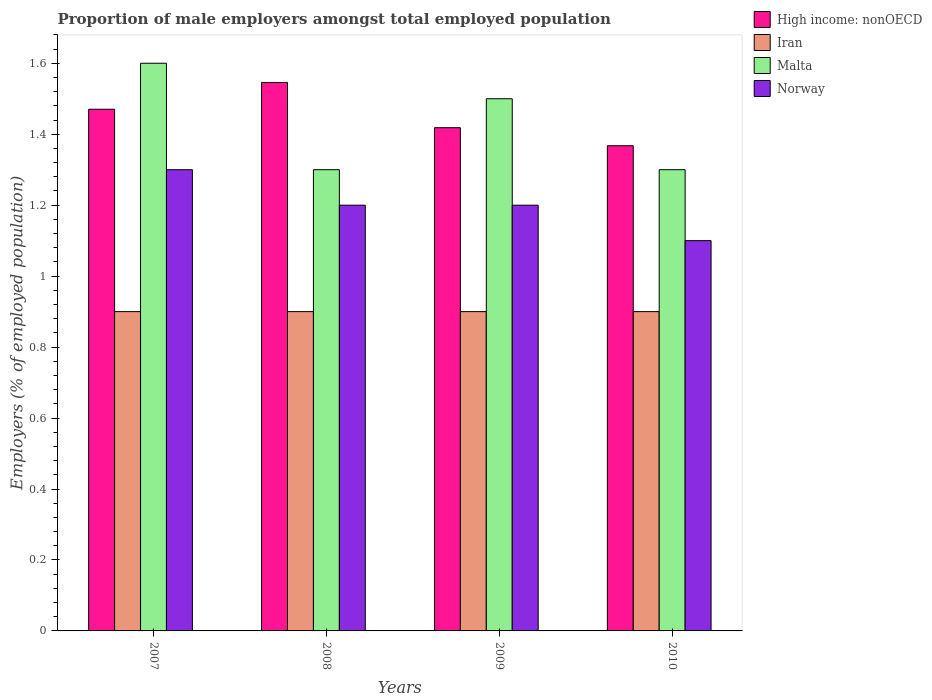How many bars are there on the 4th tick from the left?
Give a very brief answer. 4. How many bars are there on the 2nd tick from the right?
Provide a succinct answer. 4. In how many cases, is the number of bars for a given year not equal to the number of legend labels?
Provide a succinct answer. 0. What is the proportion of male employers in Norway in 2010?
Your answer should be compact. 1.1. Across all years, what is the maximum proportion of male employers in High income: nonOECD?
Give a very brief answer. 1.55. Across all years, what is the minimum proportion of male employers in Malta?
Ensure brevity in your answer.  1.3. In which year was the proportion of male employers in Norway minimum?
Provide a short and direct response. 2010. What is the total proportion of male employers in Norway in the graph?
Ensure brevity in your answer.  4.8. What is the difference between the proportion of male employers in Norway in 2007 and the proportion of male employers in Iran in 2009?
Your answer should be very brief. 0.4. What is the average proportion of male employers in Norway per year?
Provide a succinct answer. 1.2. In the year 2008, what is the difference between the proportion of male employers in Norway and proportion of male employers in High income: nonOECD?
Offer a terse response. -0.35. What is the ratio of the proportion of male employers in Norway in 2008 to that in 2009?
Your answer should be very brief. 1. Is the proportion of male employers in Iran in 2007 less than that in 2008?
Give a very brief answer. No. Is the difference between the proportion of male employers in Norway in 2008 and 2010 greater than the difference between the proportion of male employers in High income: nonOECD in 2008 and 2010?
Keep it short and to the point. No. What is the difference between the highest and the second highest proportion of male employers in Malta?
Offer a very short reply. 0.1. What is the difference between the highest and the lowest proportion of male employers in Malta?
Provide a succinct answer. 0.3. In how many years, is the proportion of male employers in High income: nonOECD greater than the average proportion of male employers in High income: nonOECD taken over all years?
Offer a very short reply. 2. What does the 2nd bar from the left in 2007 represents?
Offer a terse response. Iran. What does the 2nd bar from the right in 2009 represents?
Your answer should be compact. Malta. Is it the case that in every year, the sum of the proportion of male employers in High income: nonOECD and proportion of male employers in Malta is greater than the proportion of male employers in Iran?
Offer a terse response. Yes. Are all the bars in the graph horizontal?
Offer a terse response. No. What is the difference between two consecutive major ticks on the Y-axis?
Provide a short and direct response. 0.2. Does the graph contain any zero values?
Give a very brief answer. No. Where does the legend appear in the graph?
Make the answer very short. Top right. How many legend labels are there?
Make the answer very short. 4. How are the legend labels stacked?
Ensure brevity in your answer.  Vertical. What is the title of the graph?
Offer a very short reply. Proportion of male employers amongst total employed population. Does "Mauritius" appear as one of the legend labels in the graph?
Keep it short and to the point. No. What is the label or title of the X-axis?
Offer a very short reply. Years. What is the label or title of the Y-axis?
Offer a very short reply. Employers (% of employed population). What is the Employers (% of employed population) in High income: nonOECD in 2007?
Your answer should be very brief. 1.47. What is the Employers (% of employed population) of Iran in 2007?
Your answer should be very brief. 0.9. What is the Employers (% of employed population) of Malta in 2007?
Your answer should be compact. 1.6. What is the Employers (% of employed population) in Norway in 2007?
Make the answer very short. 1.3. What is the Employers (% of employed population) of High income: nonOECD in 2008?
Your response must be concise. 1.55. What is the Employers (% of employed population) of Iran in 2008?
Give a very brief answer. 0.9. What is the Employers (% of employed population) of Malta in 2008?
Provide a succinct answer. 1.3. What is the Employers (% of employed population) of Norway in 2008?
Your answer should be compact. 1.2. What is the Employers (% of employed population) in High income: nonOECD in 2009?
Provide a succinct answer. 1.42. What is the Employers (% of employed population) in Iran in 2009?
Keep it short and to the point. 0.9. What is the Employers (% of employed population) in Norway in 2009?
Offer a terse response. 1.2. What is the Employers (% of employed population) of High income: nonOECD in 2010?
Keep it short and to the point. 1.37. What is the Employers (% of employed population) of Iran in 2010?
Keep it short and to the point. 0.9. What is the Employers (% of employed population) in Malta in 2010?
Make the answer very short. 1.3. What is the Employers (% of employed population) of Norway in 2010?
Provide a succinct answer. 1.1. Across all years, what is the maximum Employers (% of employed population) of High income: nonOECD?
Provide a short and direct response. 1.55. Across all years, what is the maximum Employers (% of employed population) of Iran?
Provide a succinct answer. 0.9. Across all years, what is the maximum Employers (% of employed population) in Malta?
Keep it short and to the point. 1.6. Across all years, what is the maximum Employers (% of employed population) in Norway?
Make the answer very short. 1.3. Across all years, what is the minimum Employers (% of employed population) in High income: nonOECD?
Offer a very short reply. 1.37. Across all years, what is the minimum Employers (% of employed population) of Iran?
Provide a succinct answer. 0.9. Across all years, what is the minimum Employers (% of employed population) of Malta?
Provide a succinct answer. 1.3. Across all years, what is the minimum Employers (% of employed population) of Norway?
Provide a short and direct response. 1.1. What is the total Employers (% of employed population) in High income: nonOECD in the graph?
Make the answer very short. 5.8. What is the total Employers (% of employed population) of Norway in the graph?
Your answer should be very brief. 4.8. What is the difference between the Employers (% of employed population) of High income: nonOECD in 2007 and that in 2008?
Make the answer very short. -0.08. What is the difference between the Employers (% of employed population) of Iran in 2007 and that in 2008?
Provide a succinct answer. 0. What is the difference between the Employers (% of employed population) in Norway in 2007 and that in 2008?
Offer a very short reply. 0.1. What is the difference between the Employers (% of employed population) of High income: nonOECD in 2007 and that in 2009?
Offer a terse response. 0.05. What is the difference between the Employers (% of employed population) in Malta in 2007 and that in 2009?
Offer a very short reply. 0.1. What is the difference between the Employers (% of employed population) of High income: nonOECD in 2007 and that in 2010?
Provide a succinct answer. 0.1. What is the difference between the Employers (% of employed population) of Iran in 2007 and that in 2010?
Provide a short and direct response. 0. What is the difference between the Employers (% of employed population) in Malta in 2007 and that in 2010?
Your response must be concise. 0.3. What is the difference between the Employers (% of employed population) of Norway in 2007 and that in 2010?
Your response must be concise. 0.2. What is the difference between the Employers (% of employed population) in High income: nonOECD in 2008 and that in 2009?
Offer a very short reply. 0.13. What is the difference between the Employers (% of employed population) of High income: nonOECD in 2008 and that in 2010?
Provide a short and direct response. 0.18. What is the difference between the Employers (% of employed population) of Iran in 2008 and that in 2010?
Keep it short and to the point. 0. What is the difference between the Employers (% of employed population) of Norway in 2008 and that in 2010?
Offer a very short reply. 0.1. What is the difference between the Employers (% of employed population) of High income: nonOECD in 2009 and that in 2010?
Provide a succinct answer. 0.05. What is the difference between the Employers (% of employed population) of Malta in 2009 and that in 2010?
Ensure brevity in your answer.  0.2. What is the difference between the Employers (% of employed population) of Norway in 2009 and that in 2010?
Provide a short and direct response. 0.1. What is the difference between the Employers (% of employed population) of High income: nonOECD in 2007 and the Employers (% of employed population) of Iran in 2008?
Your answer should be very brief. 0.57. What is the difference between the Employers (% of employed population) in High income: nonOECD in 2007 and the Employers (% of employed population) in Malta in 2008?
Offer a very short reply. 0.17. What is the difference between the Employers (% of employed population) of High income: nonOECD in 2007 and the Employers (% of employed population) of Norway in 2008?
Provide a succinct answer. 0.27. What is the difference between the Employers (% of employed population) of Iran in 2007 and the Employers (% of employed population) of Malta in 2008?
Offer a very short reply. -0.4. What is the difference between the Employers (% of employed population) in Malta in 2007 and the Employers (% of employed population) in Norway in 2008?
Ensure brevity in your answer.  0.4. What is the difference between the Employers (% of employed population) of High income: nonOECD in 2007 and the Employers (% of employed population) of Iran in 2009?
Make the answer very short. 0.57. What is the difference between the Employers (% of employed population) of High income: nonOECD in 2007 and the Employers (% of employed population) of Malta in 2009?
Your response must be concise. -0.03. What is the difference between the Employers (% of employed population) of High income: nonOECD in 2007 and the Employers (% of employed population) of Norway in 2009?
Your response must be concise. 0.27. What is the difference between the Employers (% of employed population) in Iran in 2007 and the Employers (% of employed population) in Norway in 2009?
Offer a terse response. -0.3. What is the difference between the Employers (% of employed population) in Malta in 2007 and the Employers (% of employed population) in Norway in 2009?
Give a very brief answer. 0.4. What is the difference between the Employers (% of employed population) in High income: nonOECD in 2007 and the Employers (% of employed population) in Iran in 2010?
Keep it short and to the point. 0.57. What is the difference between the Employers (% of employed population) in High income: nonOECD in 2007 and the Employers (% of employed population) in Malta in 2010?
Make the answer very short. 0.17. What is the difference between the Employers (% of employed population) in High income: nonOECD in 2007 and the Employers (% of employed population) in Norway in 2010?
Ensure brevity in your answer.  0.37. What is the difference between the Employers (% of employed population) in Iran in 2007 and the Employers (% of employed population) in Malta in 2010?
Offer a terse response. -0.4. What is the difference between the Employers (% of employed population) in High income: nonOECD in 2008 and the Employers (% of employed population) in Iran in 2009?
Offer a very short reply. 0.65. What is the difference between the Employers (% of employed population) in High income: nonOECD in 2008 and the Employers (% of employed population) in Malta in 2009?
Provide a short and direct response. 0.05. What is the difference between the Employers (% of employed population) of High income: nonOECD in 2008 and the Employers (% of employed population) of Norway in 2009?
Provide a succinct answer. 0.35. What is the difference between the Employers (% of employed population) in Iran in 2008 and the Employers (% of employed population) in Malta in 2009?
Provide a succinct answer. -0.6. What is the difference between the Employers (% of employed population) of Iran in 2008 and the Employers (% of employed population) of Norway in 2009?
Provide a succinct answer. -0.3. What is the difference between the Employers (% of employed population) of High income: nonOECD in 2008 and the Employers (% of employed population) of Iran in 2010?
Provide a short and direct response. 0.65. What is the difference between the Employers (% of employed population) of High income: nonOECD in 2008 and the Employers (% of employed population) of Malta in 2010?
Offer a terse response. 0.25. What is the difference between the Employers (% of employed population) in High income: nonOECD in 2008 and the Employers (% of employed population) in Norway in 2010?
Provide a short and direct response. 0.45. What is the difference between the Employers (% of employed population) of Iran in 2008 and the Employers (% of employed population) of Malta in 2010?
Provide a succinct answer. -0.4. What is the difference between the Employers (% of employed population) in Iran in 2008 and the Employers (% of employed population) in Norway in 2010?
Your response must be concise. -0.2. What is the difference between the Employers (% of employed population) in Malta in 2008 and the Employers (% of employed population) in Norway in 2010?
Provide a short and direct response. 0.2. What is the difference between the Employers (% of employed population) in High income: nonOECD in 2009 and the Employers (% of employed population) in Iran in 2010?
Give a very brief answer. 0.52. What is the difference between the Employers (% of employed population) of High income: nonOECD in 2009 and the Employers (% of employed population) of Malta in 2010?
Keep it short and to the point. 0.12. What is the difference between the Employers (% of employed population) in High income: nonOECD in 2009 and the Employers (% of employed population) in Norway in 2010?
Keep it short and to the point. 0.32. What is the difference between the Employers (% of employed population) in Iran in 2009 and the Employers (% of employed population) in Norway in 2010?
Make the answer very short. -0.2. What is the difference between the Employers (% of employed population) in Malta in 2009 and the Employers (% of employed population) in Norway in 2010?
Give a very brief answer. 0.4. What is the average Employers (% of employed population) of High income: nonOECD per year?
Your answer should be compact. 1.45. What is the average Employers (% of employed population) in Iran per year?
Your answer should be compact. 0.9. What is the average Employers (% of employed population) in Malta per year?
Your answer should be compact. 1.43. In the year 2007, what is the difference between the Employers (% of employed population) in High income: nonOECD and Employers (% of employed population) in Iran?
Give a very brief answer. 0.57. In the year 2007, what is the difference between the Employers (% of employed population) in High income: nonOECD and Employers (% of employed population) in Malta?
Your answer should be very brief. -0.13. In the year 2007, what is the difference between the Employers (% of employed population) of High income: nonOECD and Employers (% of employed population) of Norway?
Make the answer very short. 0.17. In the year 2007, what is the difference between the Employers (% of employed population) in Malta and Employers (% of employed population) in Norway?
Make the answer very short. 0.3. In the year 2008, what is the difference between the Employers (% of employed population) in High income: nonOECD and Employers (% of employed population) in Iran?
Offer a terse response. 0.65. In the year 2008, what is the difference between the Employers (% of employed population) of High income: nonOECD and Employers (% of employed population) of Malta?
Ensure brevity in your answer.  0.25. In the year 2008, what is the difference between the Employers (% of employed population) of High income: nonOECD and Employers (% of employed population) of Norway?
Provide a succinct answer. 0.35. In the year 2009, what is the difference between the Employers (% of employed population) in High income: nonOECD and Employers (% of employed population) in Iran?
Ensure brevity in your answer.  0.52. In the year 2009, what is the difference between the Employers (% of employed population) in High income: nonOECD and Employers (% of employed population) in Malta?
Your answer should be compact. -0.08. In the year 2009, what is the difference between the Employers (% of employed population) of High income: nonOECD and Employers (% of employed population) of Norway?
Give a very brief answer. 0.22. In the year 2010, what is the difference between the Employers (% of employed population) of High income: nonOECD and Employers (% of employed population) of Iran?
Offer a very short reply. 0.47. In the year 2010, what is the difference between the Employers (% of employed population) of High income: nonOECD and Employers (% of employed population) of Malta?
Provide a short and direct response. 0.07. In the year 2010, what is the difference between the Employers (% of employed population) of High income: nonOECD and Employers (% of employed population) of Norway?
Keep it short and to the point. 0.27. In the year 2010, what is the difference between the Employers (% of employed population) of Malta and Employers (% of employed population) of Norway?
Your response must be concise. 0.2. What is the ratio of the Employers (% of employed population) in High income: nonOECD in 2007 to that in 2008?
Offer a terse response. 0.95. What is the ratio of the Employers (% of employed population) in Iran in 2007 to that in 2008?
Make the answer very short. 1. What is the ratio of the Employers (% of employed population) in Malta in 2007 to that in 2008?
Provide a succinct answer. 1.23. What is the ratio of the Employers (% of employed population) in Norway in 2007 to that in 2008?
Offer a very short reply. 1.08. What is the ratio of the Employers (% of employed population) in High income: nonOECD in 2007 to that in 2009?
Keep it short and to the point. 1.04. What is the ratio of the Employers (% of employed population) in Malta in 2007 to that in 2009?
Provide a succinct answer. 1.07. What is the ratio of the Employers (% of employed population) of High income: nonOECD in 2007 to that in 2010?
Your response must be concise. 1.08. What is the ratio of the Employers (% of employed population) of Malta in 2007 to that in 2010?
Keep it short and to the point. 1.23. What is the ratio of the Employers (% of employed population) in Norway in 2007 to that in 2010?
Your answer should be very brief. 1.18. What is the ratio of the Employers (% of employed population) in High income: nonOECD in 2008 to that in 2009?
Give a very brief answer. 1.09. What is the ratio of the Employers (% of employed population) in Iran in 2008 to that in 2009?
Offer a terse response. 1. What is the ratio of the Employers (% of employed population) of Malta in 2008 to that in 2009?
Your response must be concise. 0.87. What is the ratio of the Employers (% of employed population) in Norway in 2008 to that in 2009?
Your answer should be compact. 1. What is the ratio of the Employers (% of employed population) of High income: nonOECD in 2008 to that in 2010?
Make the answer very short. 1.13. What is the ratio of the Employers (% of employed population) of Iran in 2008 to that in 2010?
Offer a terse response. 1. What is the ratio of the Employers (% of employed population) of Norway in 2008 to that in 2010?
Your answer should be very brief. 1.09. What is the ratio of the Employers (% of employed population) of High income: nonOECD in 2009 to that in 2010?
Make the answer very short. 1.04. What is the ratio of the Employers (% of employed population) in Malta in 2009 to that in 2010?
Offer a terse response. 1.15. What is the difference between the highest and the second highest Employers (% of employed population) in High income: nonOECD?
Your answer should be very brief. 0.08. What is the difference between the highest and the second highest Employers (% of employed population) of Malta?
Ensure brevity in your answer.  0.1. What is the difference between the highest and the second highest Employers (% of employed population) in Norway?
Offer a terse response. 0.1. What is the difference between the highest and the lowest Employers (% of employed population) of High income: nonOECD?
Provide a succinct answer. 0.18. What is the difference between the highest and the lowest Employers (% of employed population) of Iran?
Ensure brevity in your answer.  0. What is the difference between the highest and the lowest Employers (% of employed population) of Malta?
Give a very brief answer. 0.3. What is the difference between the highest and the lowest Employers (% of employed population) in Norway?
Offer a very short reply. 0.2. 